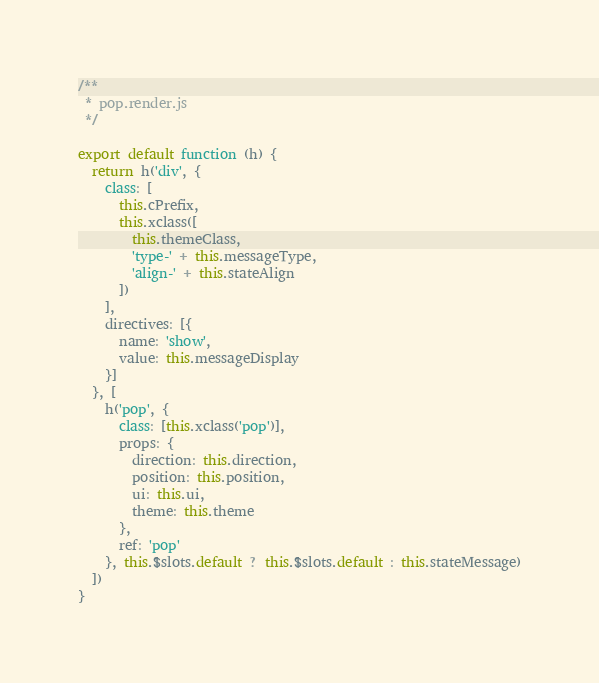<code> <loc_0><loc_0><loc_500><loc_500><_JavaScript_>/**
 * pop.render.js
 */

export default function (h) {
  return h('div', {
    class: [
      this.cPrefix,
      this.xclass([
        this.themeClass,
        'type-' + this.messageType,
        'align-' + this.stateAlign
      ])
    ],
    directives: [{
      name: 'show',
      value: this.messageDisplay
    }]
  }, [
    h('pop', {
      class: [this.xclass('pop')],
      props: {
        direction: this.direction,
        position: this.position,
        ui: this.ui,
        theme: this.theme
      },
      ref: 'pop'
    }, this.$slots.default ? this.$slots.default : this.stateMessage)
  ])
}
</code> 